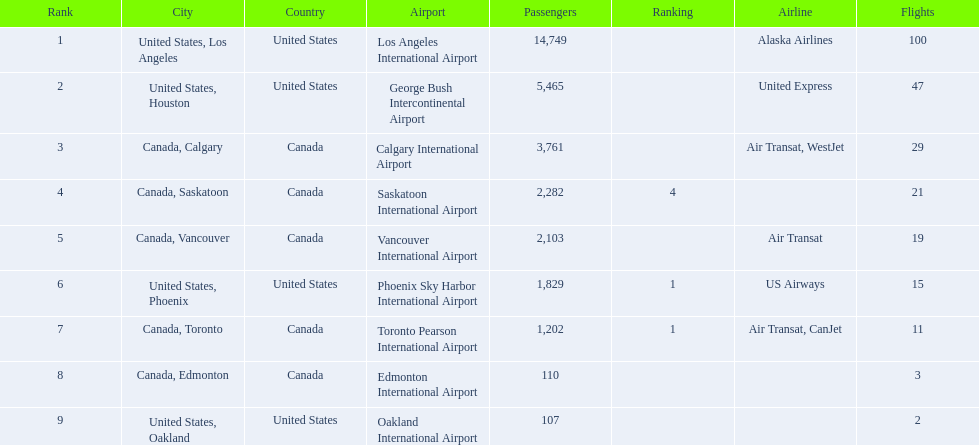Which cities had less than 2,000 passengers? United States, Phoenix, Canada, Toronto, Canada, Edmonton, United States, Oakland. Of these cities, which had fewer than 1,000 passengers? Canada, Edmonton, United States, Oakland. Of the cities in the previous answer, which one had only 107 passengers? United States, Oakland. 